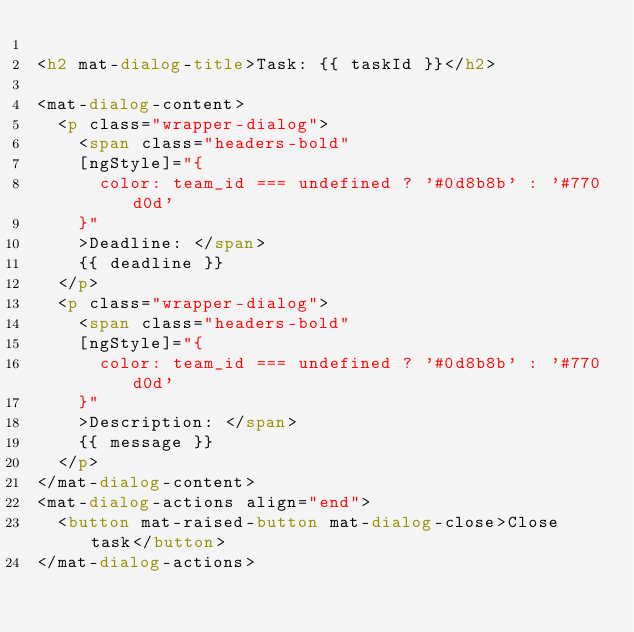<code> <loc_0><loc_0><loc_500><loc_500><_HTML_>
<h2 mat-dialog-title>Task: {{ taskId }}</h2>

<mat-dialog-content>
  <p class="wrapper-dialog">
    <span class="headers-bold" 
    [ngStyle]="{
      color: team_id === undefined ? '#0d8b8b' : '#770d0d'
    }"
    >Deadline: </span>
    {{ deadline }}
  </p>
  <p class="wrapper-dialog">
    <span class="headers-bold"
    [ngStyle]="{
      color: team_id === undefined ? '#0d8b8b' : '#770d0d'
    }"
    >Description: </span>
    {{ message }}
  </p>
</mat-dialog-content>
<mat-dialog-actions align="end">
  <button mat-raised-button mat-dialog-close>Close task</button>
</mat-dialog-actions>
</code> 